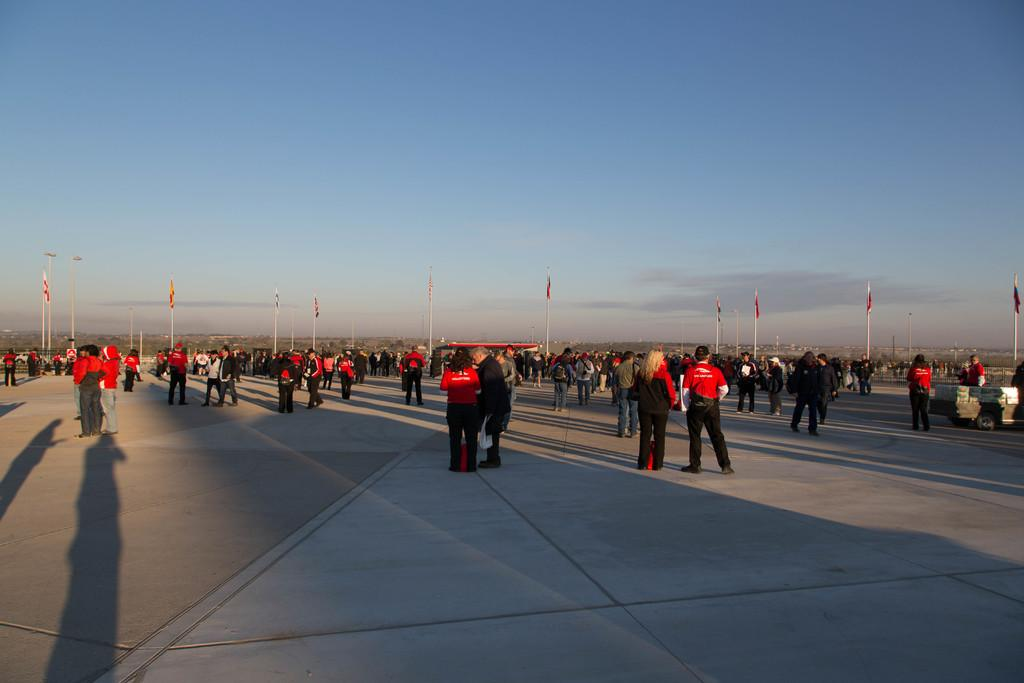What is happening in the image? There are people standing in an open area. What can be seen in the background of the image? There is a flag pole in the background. What is the color of the sky in the image? The sky is blue. How many roots can be seen growing from the flag pole in the image? There are no roots visible in the image, as the focus is on the people and the flag pole, not any plant life. 